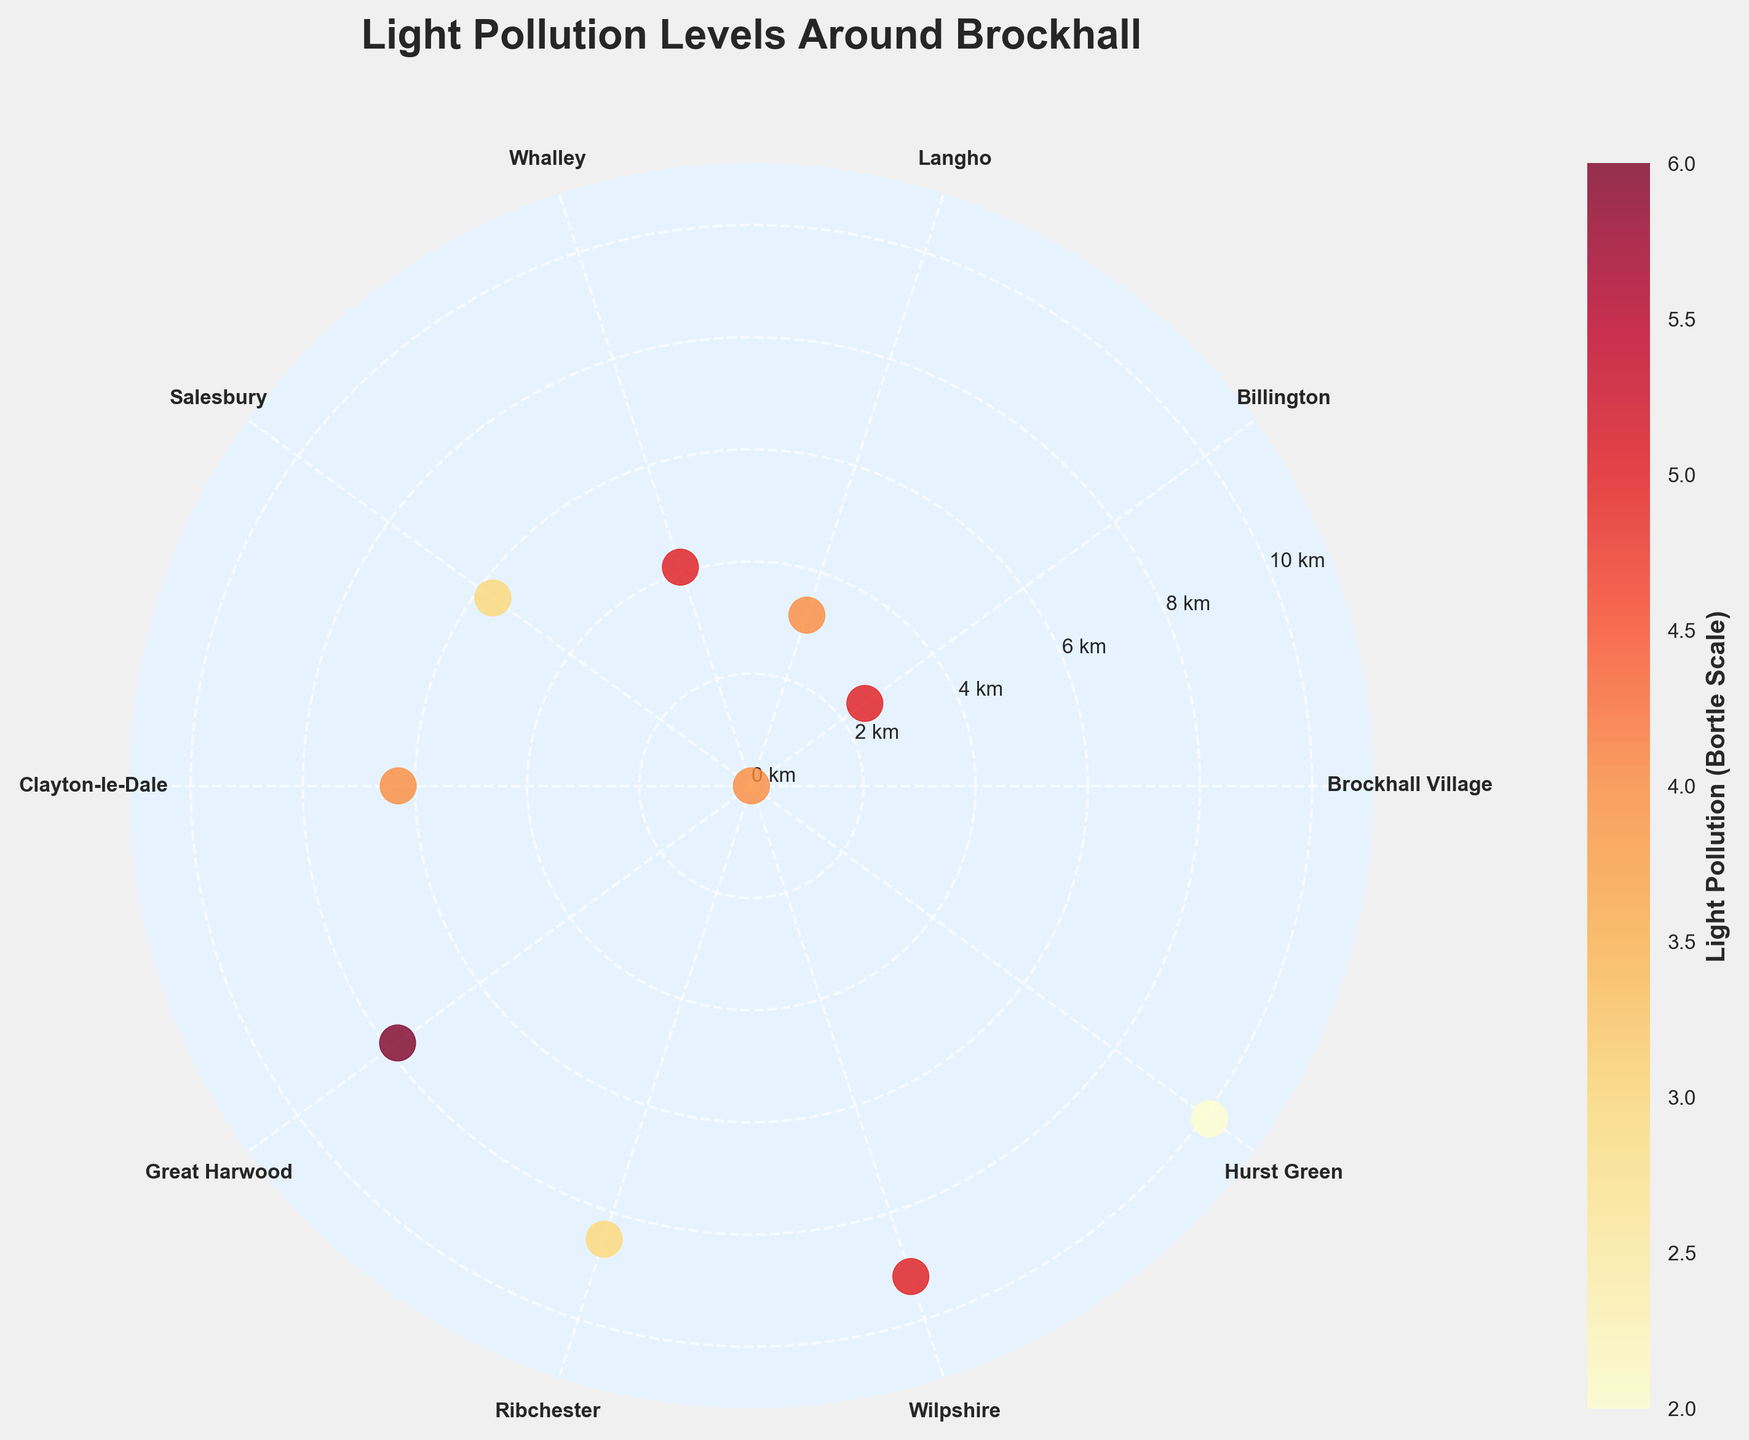What is the title of the figure? The title of the figure is usually the largest text and placed at the top. In this case, it reads "Light Pollution Levels Around Brockhall"
Answer: Light Pollution Levels Around Brockhall How many locations are listed around Brockhall? The locations can be counted by looking at the angular tick labels in the polar plot. They are Brockhall Village, Billington, Langho, Whalley, Salesbury, Clayton-le-Dale, Great Harwood, Ribchester, Wilpshire, and Hurst Green.
Answer: 10 Which location has the lowest light pollution level? By looking at the color bar and the color of the data points in the plot, Hurst Green sits at the lowest end of the Bortle scale with a value of 2, represented by the darkest point.
Answer: Hurst Green Which location is the furthest from Brockhall? The maximum radial distance from the center point of Brockhall will indicate the furthest location. Hurst Green is situated at the outermost edge with a distance of 10.1 km.
Answer: Hurst Green What color represents the highest light pollution level on the color bar? By checking the color bar, the highest light pollution value (Bortle scale of 6) is represented by the deepest red color.
Answer: Deep red Which two locations have the same light pollution level but different distances from Brockhall? Clayton-le-Dale and Langho both have a light pollution level of 4 but different distances of 6.3 km and 3.2 km respectively.
Answer: Clayton-le-Dale and Langho What is the light pollution level at Ribchester and its distance from Brockhall? Ribchester is marked on the plot with a certain color corresponding to the Bortle scale. Its radial distance also specifies how far it is from Brockhall. Ribchester shows a light pollution level of 3 and is 8.5 km away.
Answer: Level 3, 8.5 km Does a lower light pollution level always correlate with a greater distance from Brockhall? Examining the figure, instances such as Salesbury (5.7 km, level 3) and Hurst Green (10.1 km, level 2) show lower pollution levels at varying distances, indicating no direct correlation.
Answer: No How many locations have a light pollution level of 5? Each location's color will correspond to a specific Bortle scale value. From the figure, Billington, Whalley, and Wilpshire all have a light pollution level of 5.
Answer: 3 locations Which location would you recommend for the best astrophotography and why? Look for the lowest light pollution level and consider its distance. Hurst Green, with the lowest light pollution level (2) and reasonable distance (10.1 km) from Brockhall, offers optimal conditions for astrophotography.
Answer: Hurst Green, lowest pollution level 2, 10.1 km 